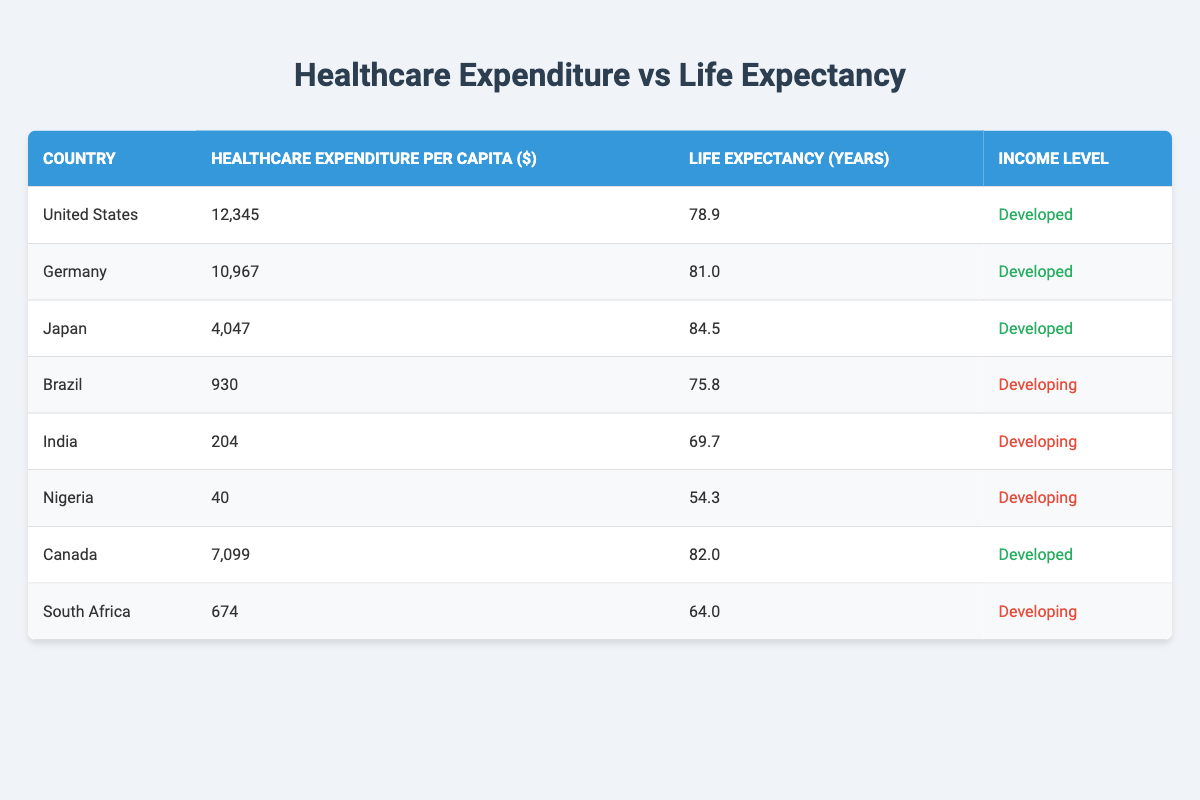What is the life expectancy of Japan? From the table, Japan has a life expectancy of 84.5 years listed in the "Life Expectancy (years)" column.
Answer: 84.5 Which country has the highest healthcare expenditure per capita? According to the table, the United States has the highest healthcare expenditure per capita, which is 12,345 dollars listed in the "Healthcare Expenditure per Capita ($)" column.
Answer: United States What is the average life expectancy for developed countries in this table? The life expectancies of developed countries listed are: 78.9 (US), 81.0 (Germany), 84.5 (Japan), and 82.0 (Canada). Summing these gives 78.9 + 81.0 + 84.5 + 82.0 = 326.4 years. There are 4 countries, so the average life expectancy is 326.4 / 4 = 81.6 years.
Answer: 81.6 Is the life expectancy in India greater than that in Brazil? From the table, India has a life expectancy of 69.7 years while Brazil has a life expectancy of 75.8 years. Since 69.7 is not greater than 75.8, the statement is false.
Answer: No What is the difference in healthcare expenditure per capita between Canada and South Africa? In the table, Canada has a healthcare expenditure per capita of 7,099 dollars and South Africa has 674 dollars. The difference is calculated as 7,099 - 674 = 6,425 dollars.
Answer: 6425 Which developing country has the lowest healthcare expenditure per capita? By reviewing the table, Nigeria has the lowest healthcare expenditure per capita at 40 dollars compared to Brazil (930) and India (204), therefore, Nigeria has the lowest.
Answer: Nigeria Is life expectancy in any developing country greater than 70 years? Referring to the table, Brazil has a life expectancy of 75.8 years, which is greater than 70, while India and Nigeria have 69.7 and 54.3 years, respectively. Therefore, there is one developing country which is Brazil.
Answer: Yes What is the average healthcare expenditure per capita for developing countries in this table? The healthcare expenditures for developing countries listed in the table are: 930 (Brazil), 204 (India), 40 (Nigeria), and 674 (South Africa). Summing these gives 930 + 204 + 40 + 674 = 1848 dollars. There are 4 countries, so the average is 1848 / 4 = 462 dollars.
Answer: 462 